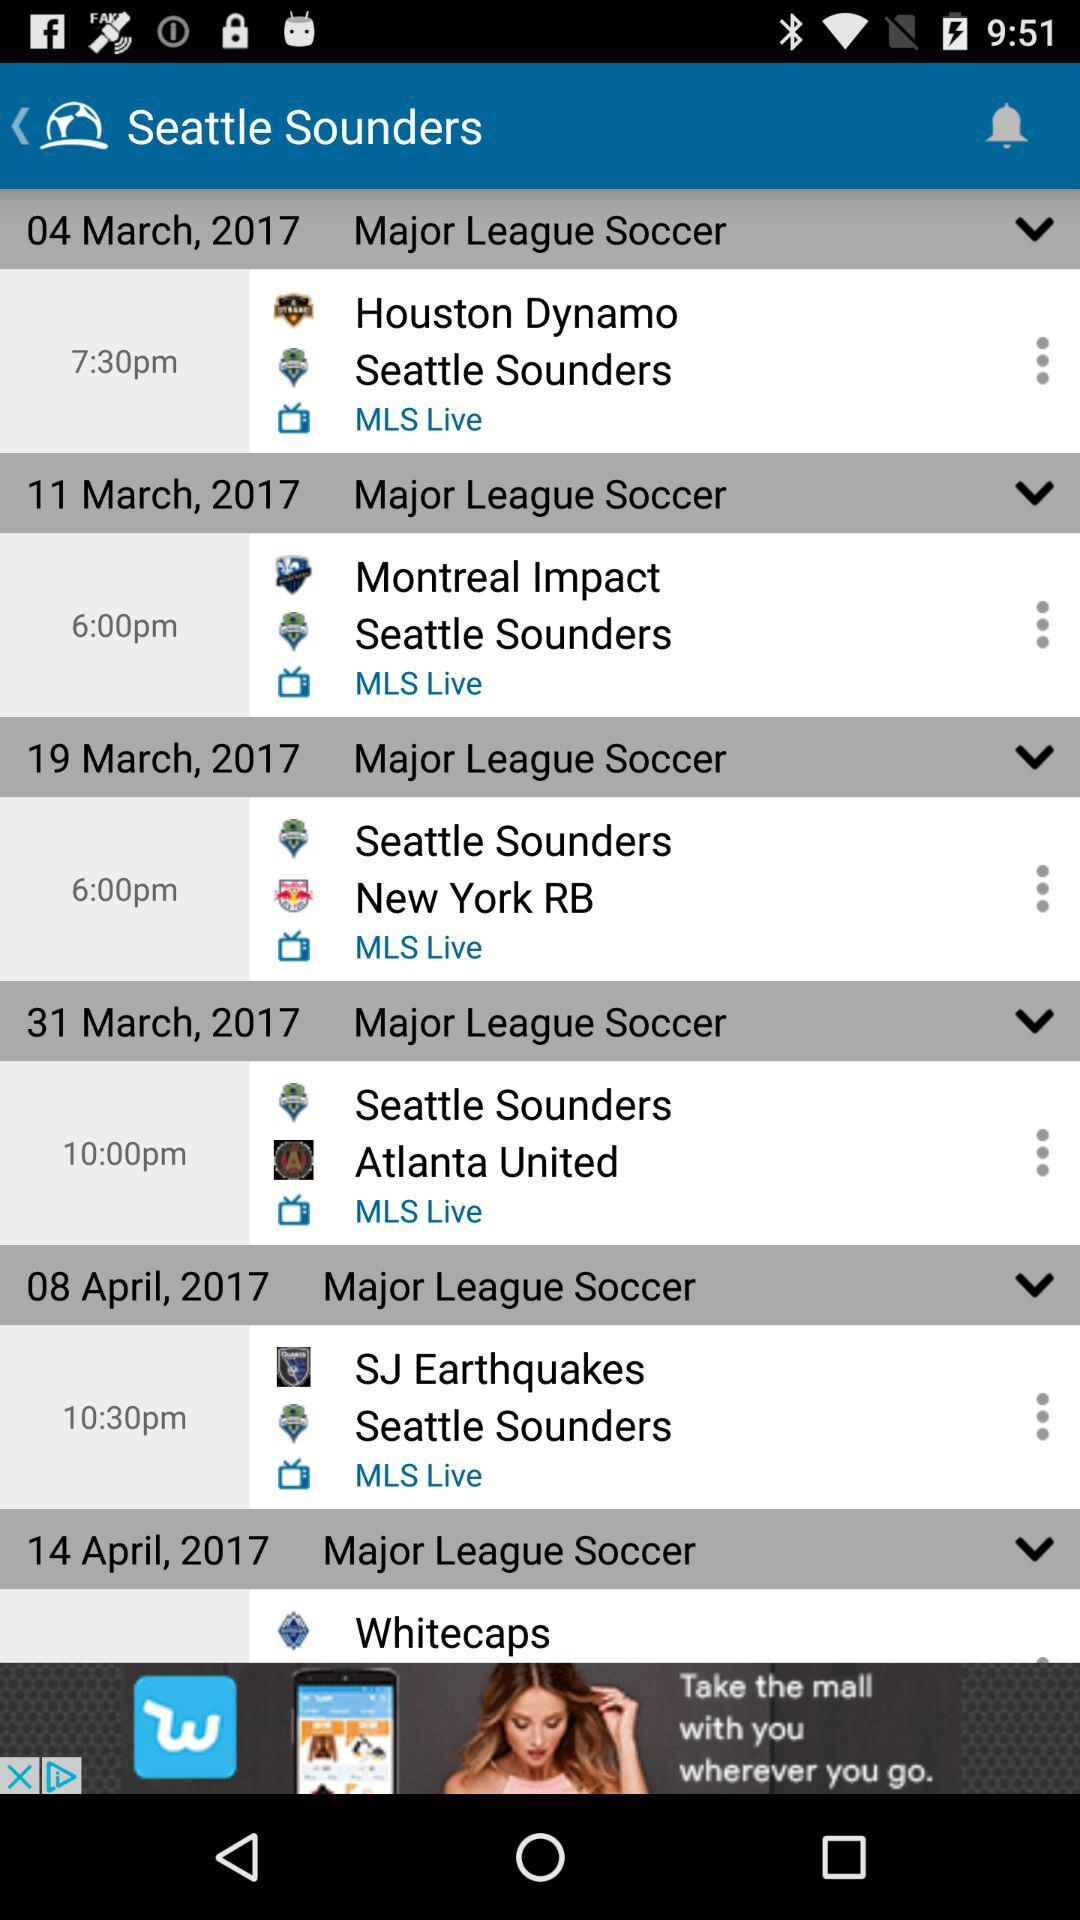What is the application name? The application name is "Seattle Sounders". 